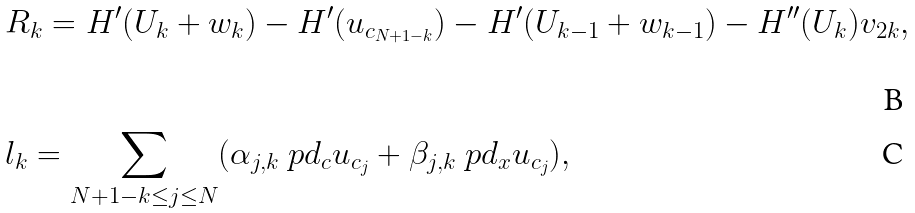Convert formula to latex. <formula><loc_0><loc_0><loc_500><loc_500>& R _ { k } = H ^ { \prime } ( U _ { k } + w _ { k } ) - H ^ { \prime } ( u _ { c _ { N + 1 - k } } ) - H ^ { \prime } ( U _ { k - 1 } + w _ { k - 1 } ) - H ^ { \prime \prime } ( U _ { k } ) v _ { 2 k } , \\ & l _ { k } = \sum _ { N + 1 - k \leq j \leq N } ( \alpha _ { j , k } \ p d _ { c } u _ { c _ { j } } + \beta _ { j , k } \ p d _ { x } u _ { c _ { j } } ) ,</formula> 